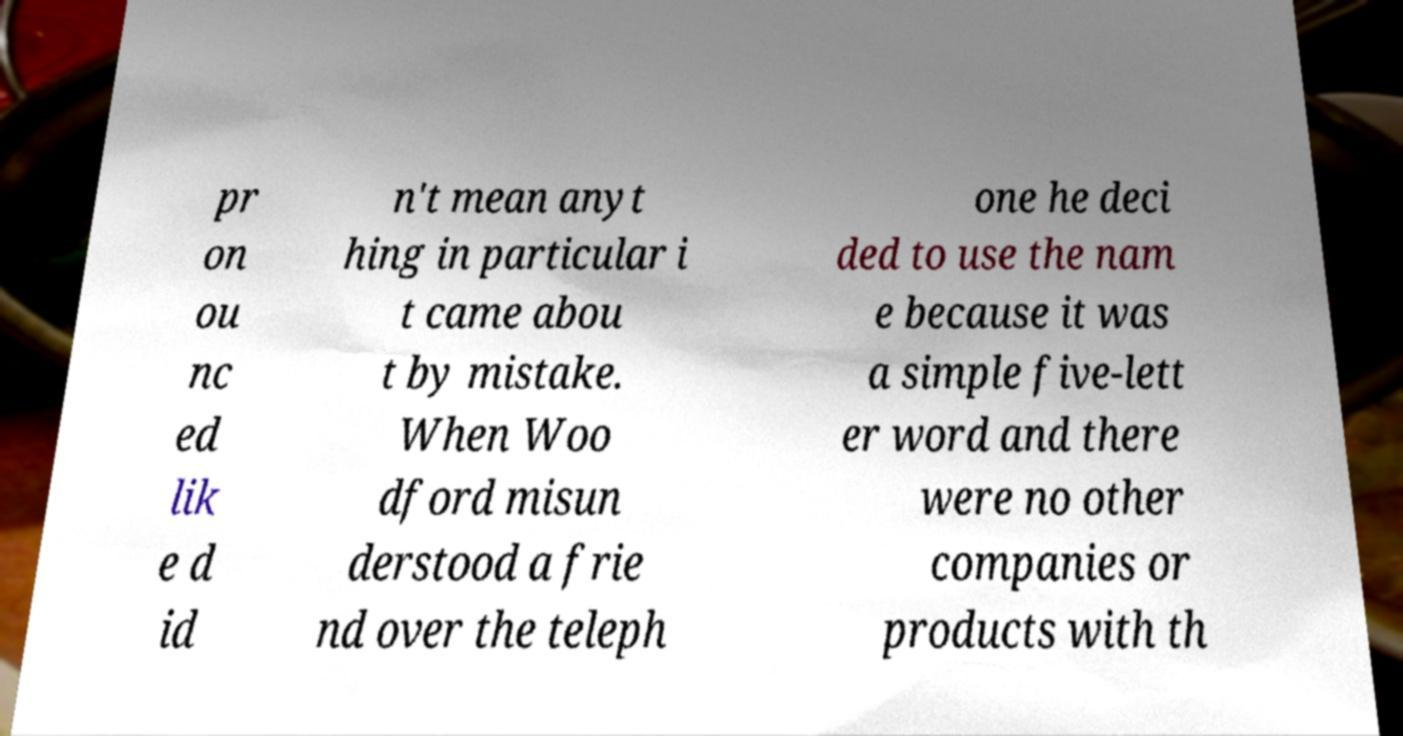Please read and relay the text visible in this image. What does it say? pr on ou nc ed lik e d id n't mean anyt hing in particular i t came abou t by mistake. When Woo dford misun derstood a frie nd over the teleph one he deci ded to use the nam e because it was a simple five-lett er word and there were no other companies or products with th 